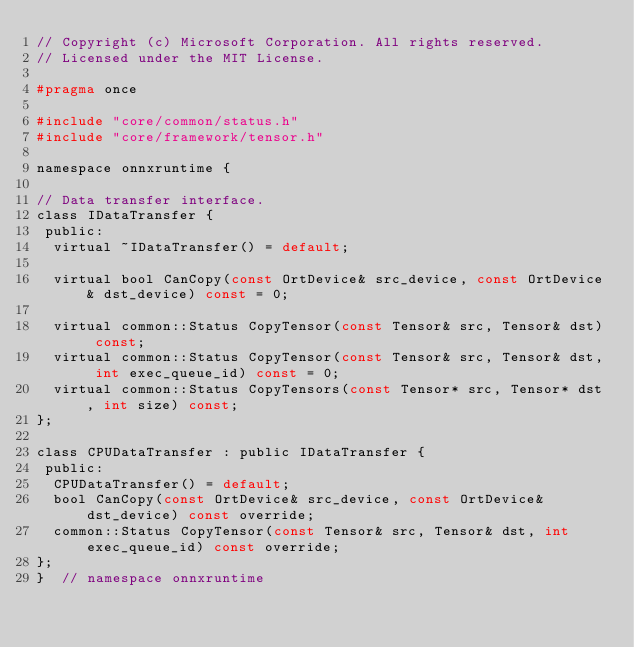<code> <loc_0><loc_0><loc_500><loc_500><_C_>// Copyright (c) Microsoft Corporation. All rights reserved.
// Licensed under the MIT License.

#pragma once

#include "core/common/status.h"
#include "core/framework/tensor.h"

namespace onnxruntime {

// Data transfer interface.
class IDataTransfer {
 public:
  virtual ~IDataTransfer() = default;

  virtual bool CanCopy(const OrtDevice& src_device, const OrtDevice& dst_device) const = 0;

  virtual common::Status CopyTensor(const Tensor& src, Tensor& dst) const;
  virtual common::Status CopyTensor(const Tensor& src, Tensor& dst, int exec_queue_id) const = 0;
  virtual common::Status CopyTensors(const Tensor* src, Tensor* dst, int size) const;
};

class CPUDataTransfer : public IDataTransfer {
 public:
  CPUDataTransfer() = default;
  bool CanCopy(const OrtDevice& src_device, const OrtDevice& dst_device) const override;
  common::Status CopyTensor(const Tensor& src, Tensor& dst, int exec_queue_id) const override;
};
}  // namespace onnxruntime
</code> 